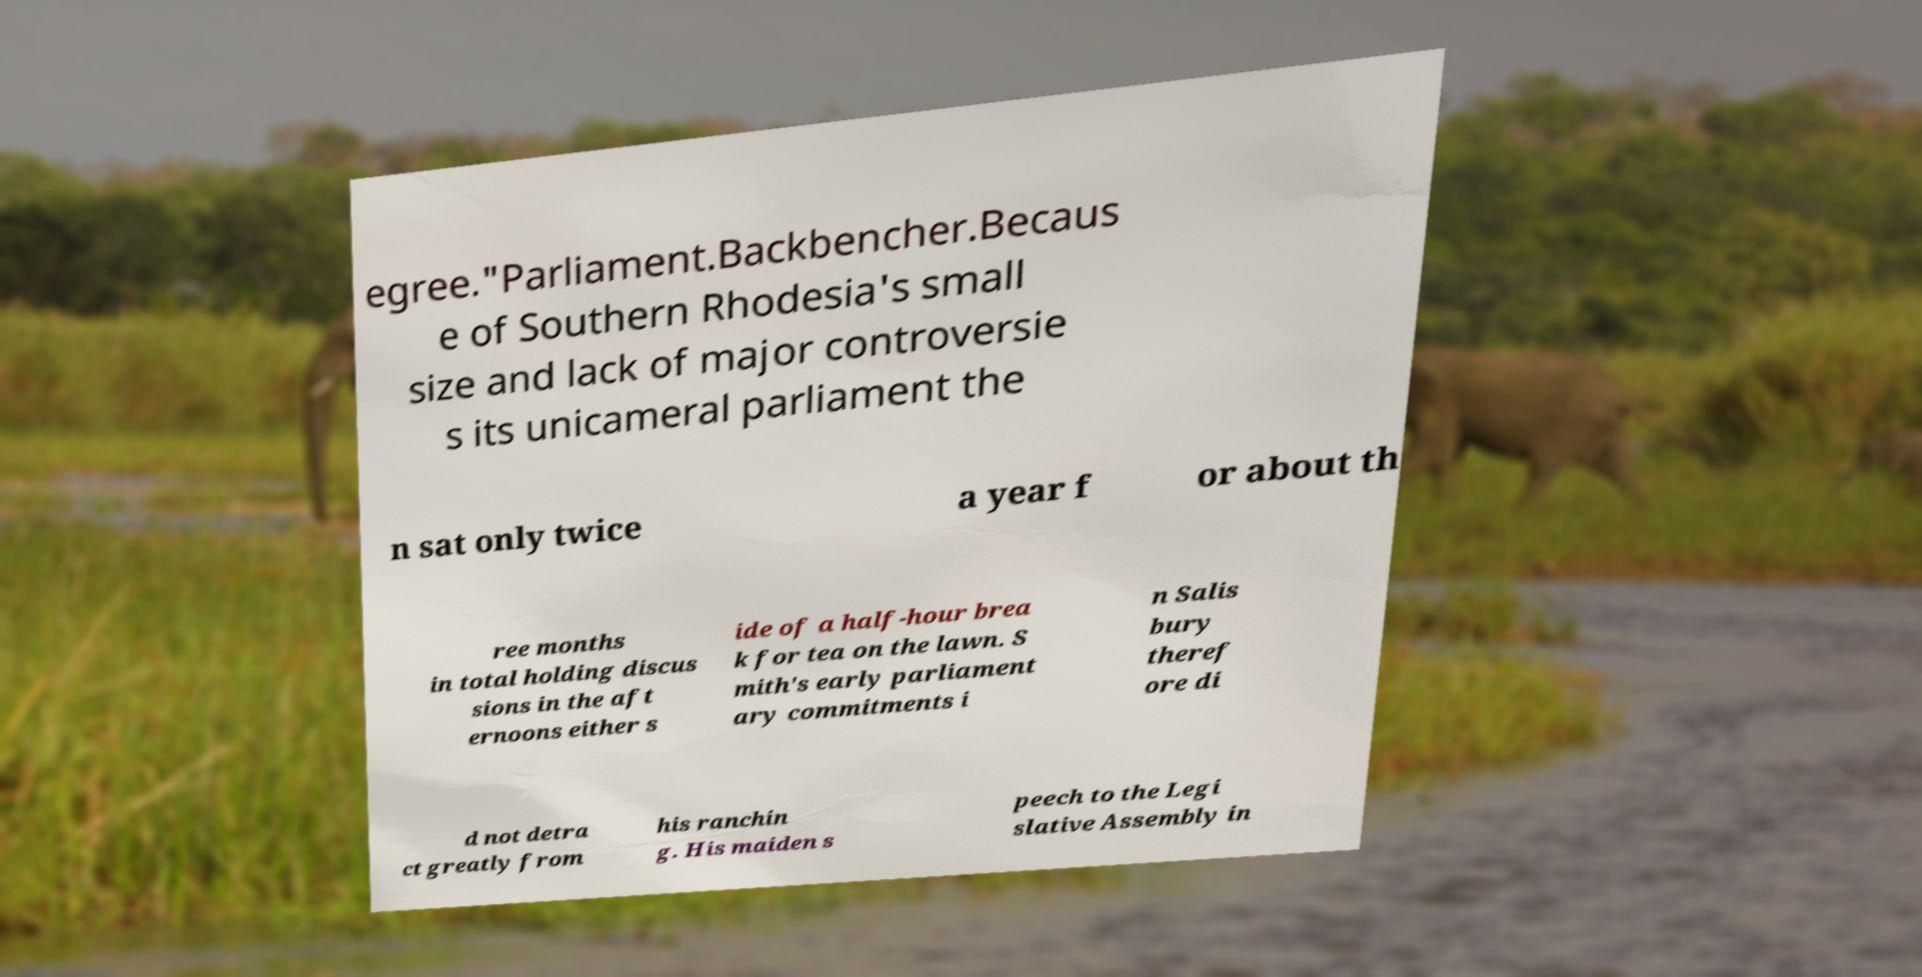What messages or text are displayed in this image? I need them in a readable, typed format. egree."Parliament.Backbencher.Becaus e of Southern Rhodesia's small size and lack of major controversie s its unicameral parliament the n sat only twice a year f or about th ree months in total holding discus sions in the aft ernoons either s ide of a half-hour brea k for tea on the lawn. S mith's early parliament ary commitments i n Salis bury theref ore di d not detra ct greatly from his ranchin g. His maiden s peech to the Legi slative Assembly in 